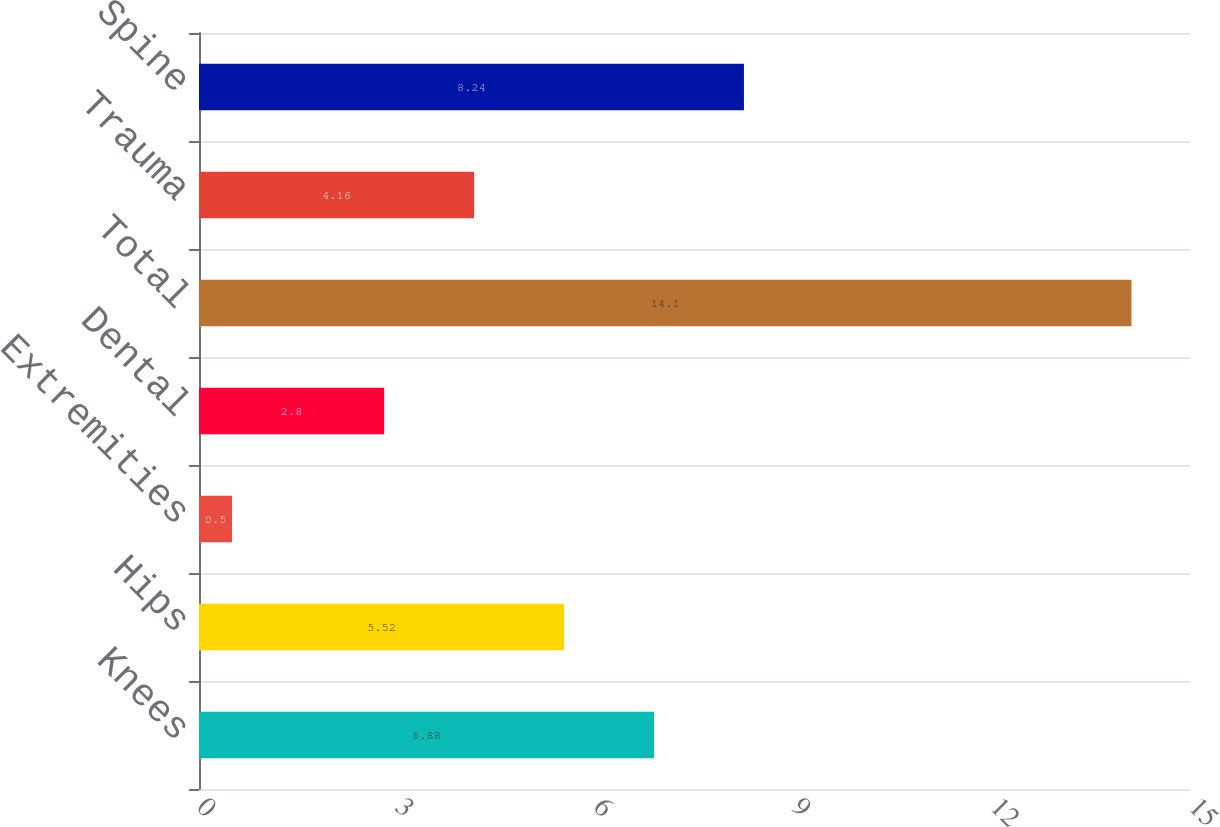Convert chart to OTSL. <chart><loc_0><loc_0><loc_500><loc_500><bar_chart><fcel>Knees<fcel>Hips<fcel>Extremities<fcel>Dental<fcel>Total<fcel>Trauma<fcel>Spine<nl><fcel>6.88<fcel>5.52<fcel>0.5<fcel>2.8<fcel>14.1<fcel>4.16<fcel>8.24<nl></chart> 